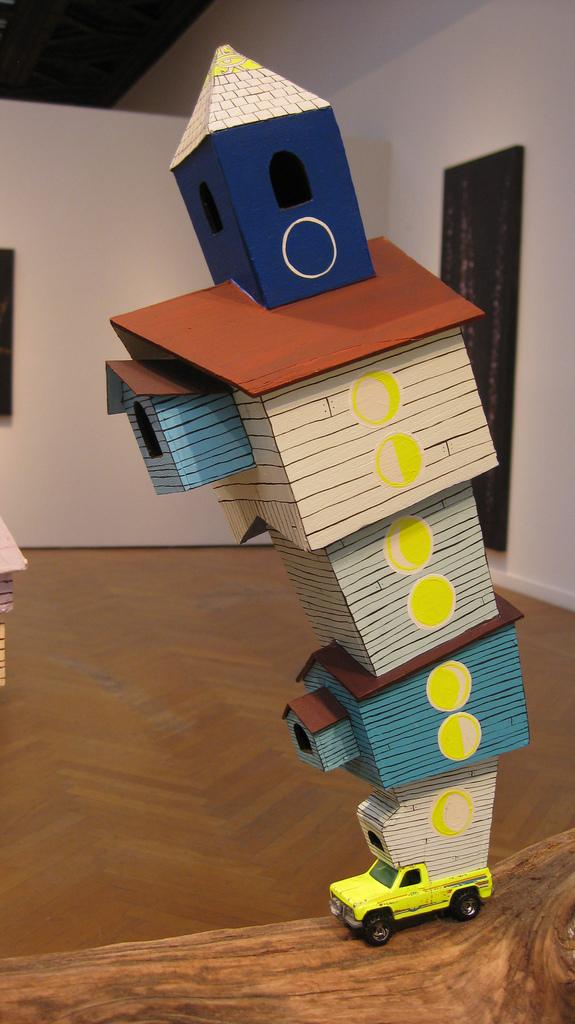What type of toy is in the image? There is a yellow toy truck in the image. What is on the toy truck? There are cardboard houses on the truck. What color is the wall in the image? The wall in the image is white. What feature is present on the wall? The wall has a window. What rule is being enforced by the fire in the image? There is no fire present in the image, so no rule can be enforced by it. 